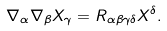<formula> <loc_0><loc_0><loc_500><loc_500>\nabla _ { \alpha } \nabla _ { \beta } X _ { \gamma } = R _ { \alpha \beta \gamma \delta } X ^ { \delta } .</formula> 